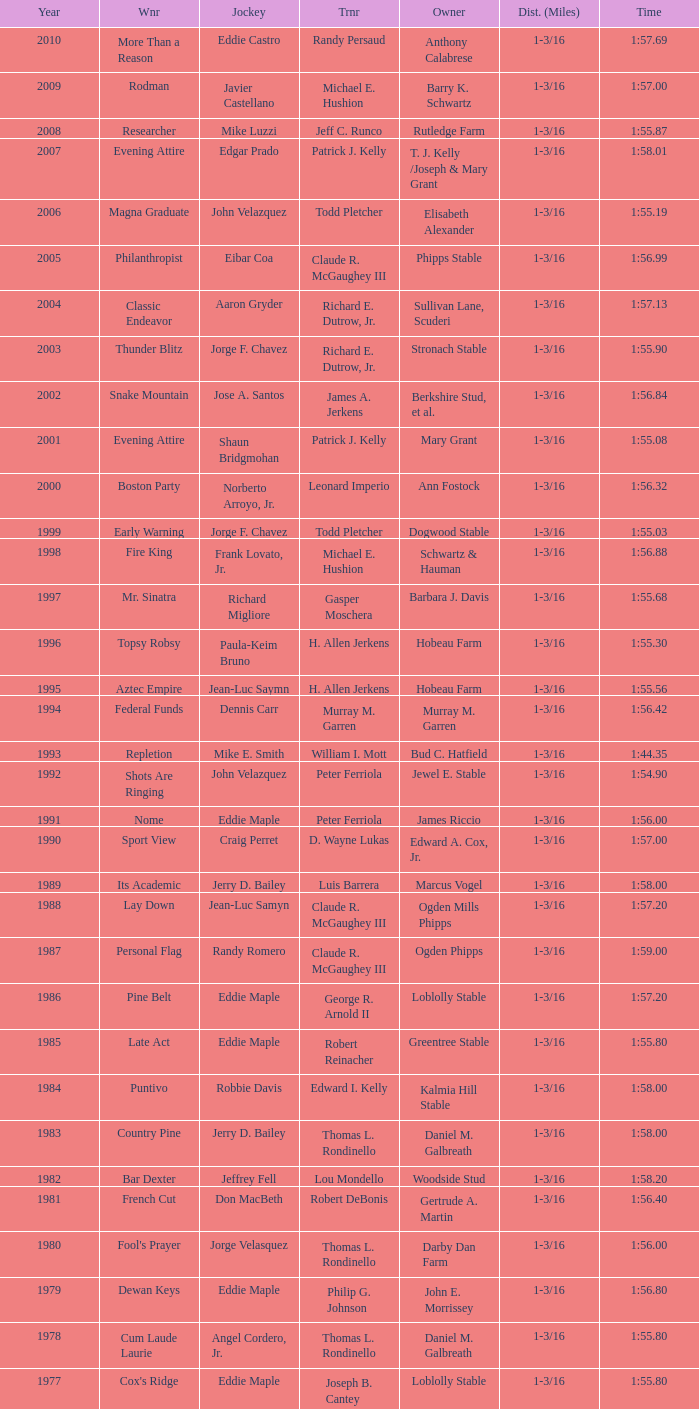What horse won with a trainer of "no race"? No Race, No Race, No Race, No Race. 